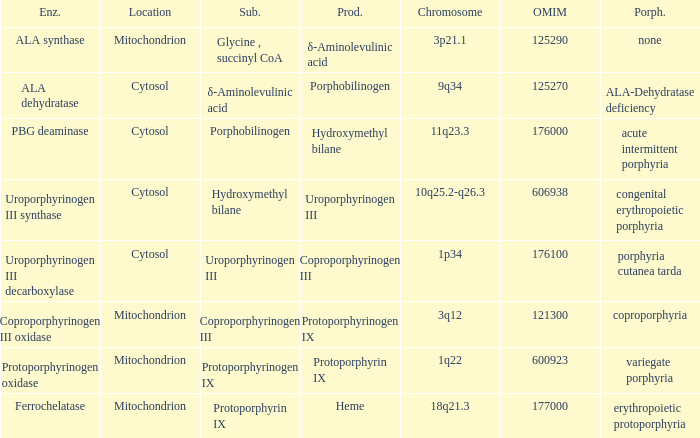Which substrate has an OMIM of 176000? Porphobilinogen. 